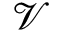<formula> <loc_0><loc_0><loc_500><loc_500>\mathcal { V }</formula> 